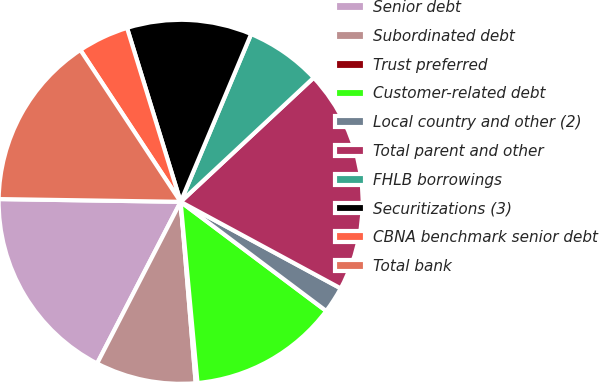<chart> <loc_0><loc_0><loc_500><loc_500><pie_chart><fcel>Senior debt<fcel>Subordinated debt<fcel>Trust preferred<fcel>Customer-related debt<fcel>Local country and other (2)<fcel>Total parent and other<fcel>FHLB borrowings<fcel>Securitizations (3)<fcel>CBNA benchmark senior debt<fcel>Total bank<nl><fcel>17.65%<fcel>8.91%<fcel>0.16%<fcel>13.28%<fcel>2.35%<fcel>19.84%<fcel>6.72%<fcel>11.09%<fcel>4.53%<fcel>15.47%<nl></chart> 